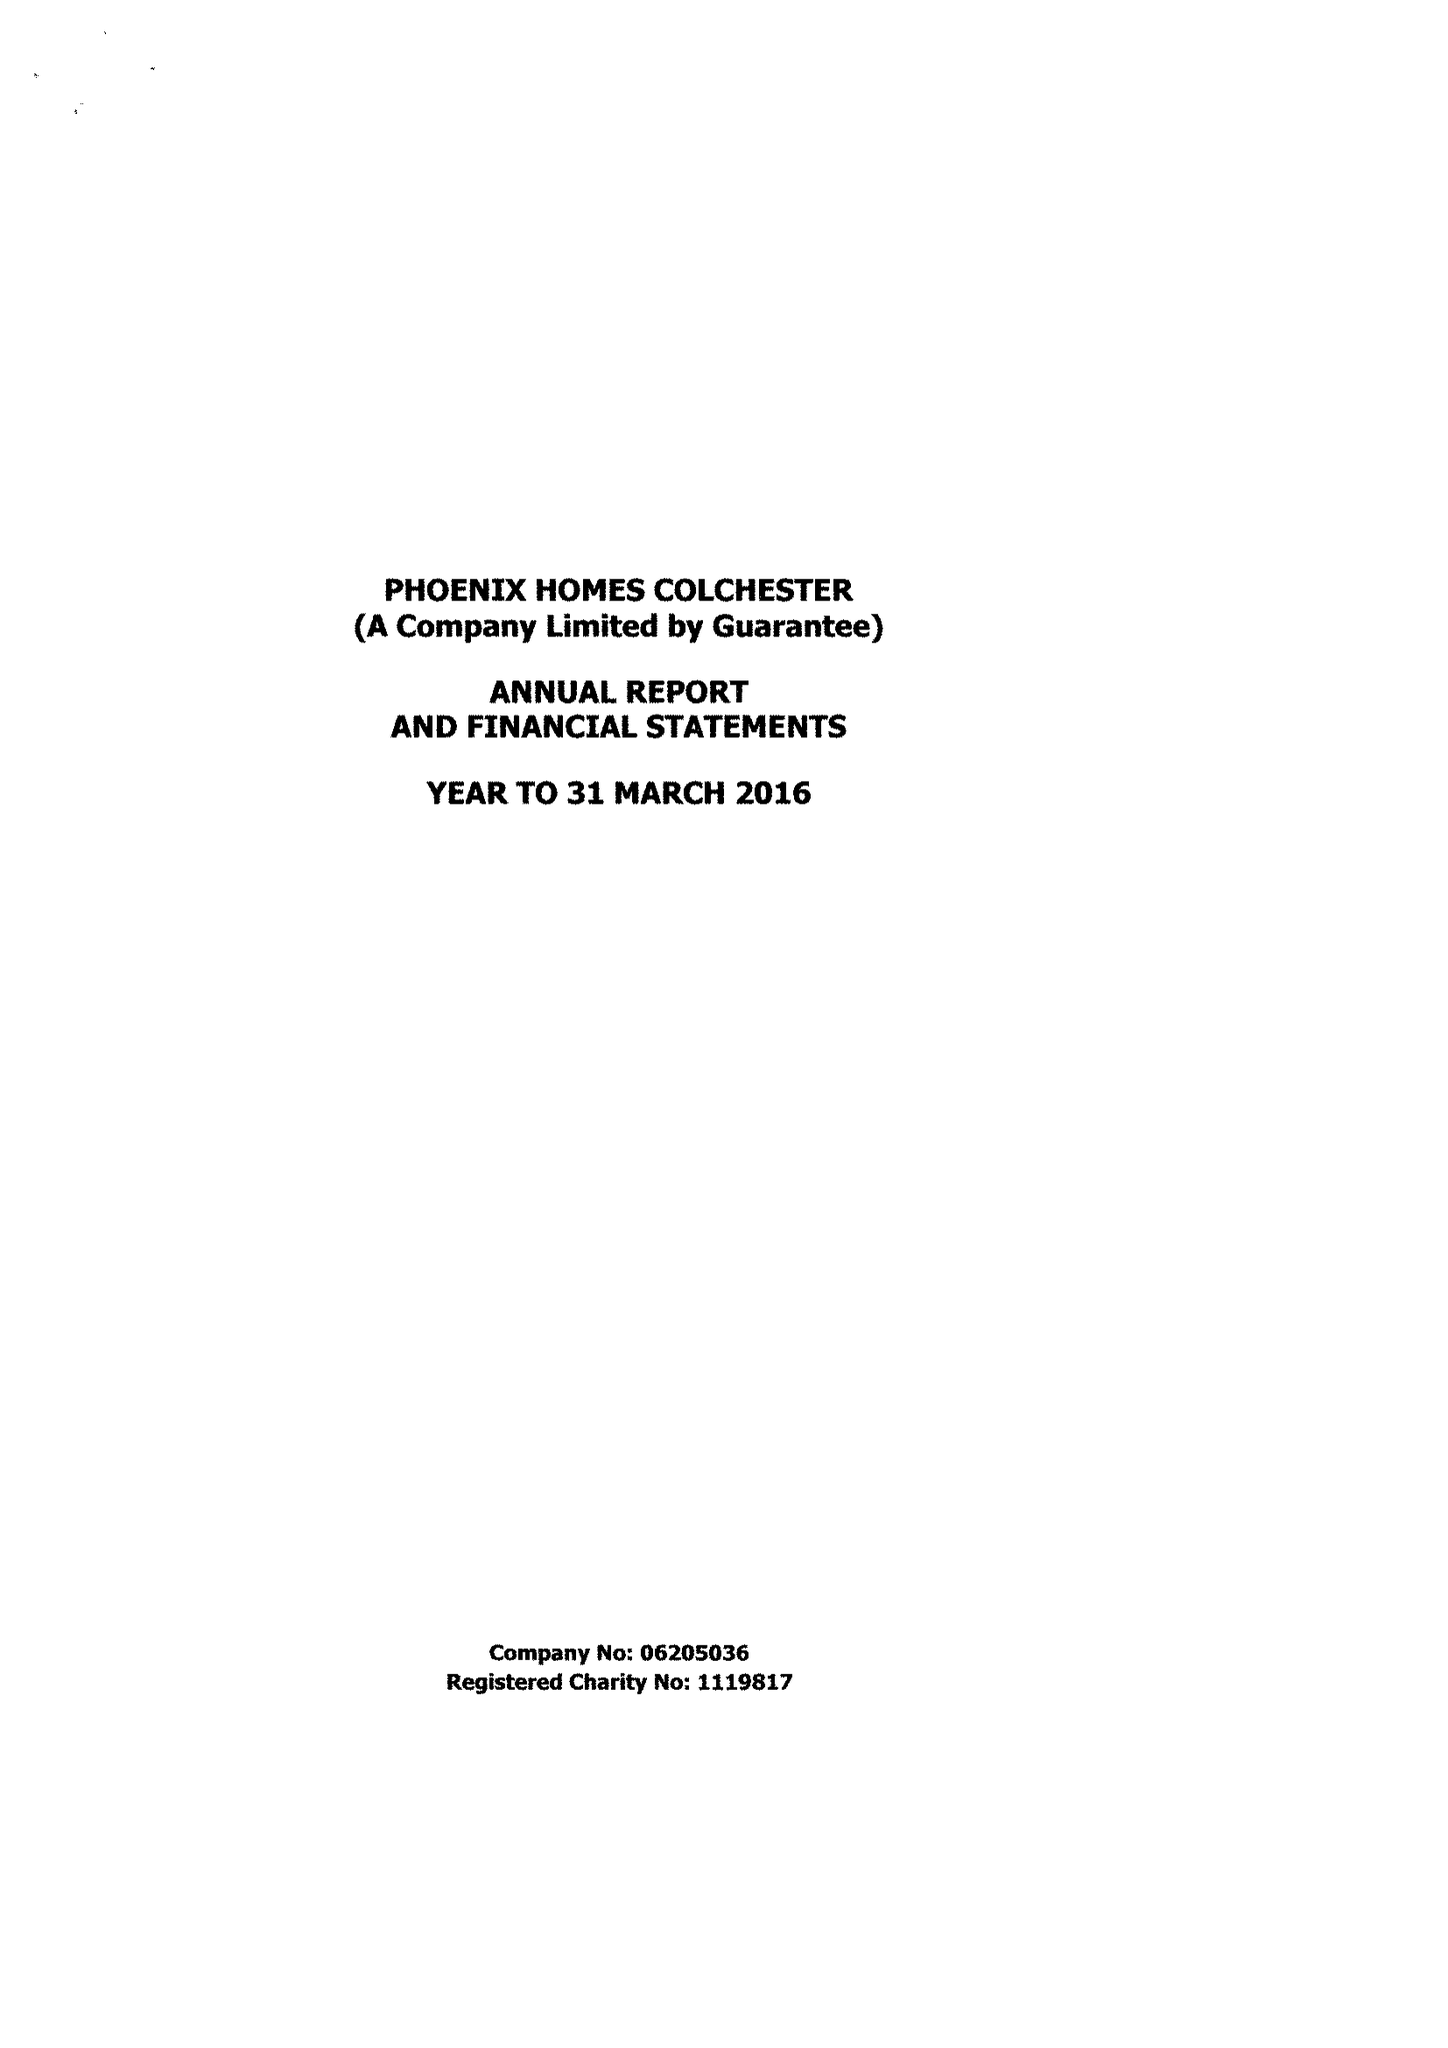What is the value for the charity_name?
Answer the question using a single word or phrase. Phoenix Homes Colchester 